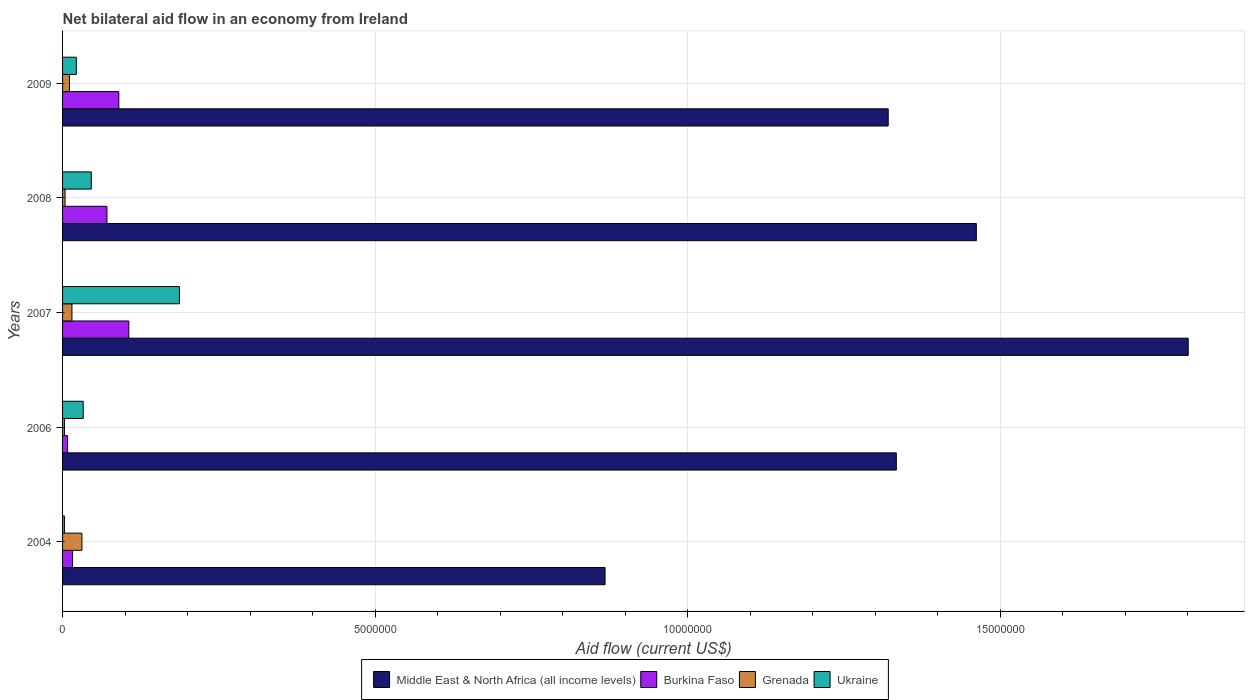How many different coloured bars are there?
Provide a short and direct response. 4. How many groups of bars are there?
Your answer should be very brief. 5. Are the number of bars on each tick of the Y-axis equal?
Your answer should be very brief. Yes. In how many cases, is the number of bars for a given year not equal to the number of legend labels?
Provide a succinct answer. 0. Across all years, what is the maximum net bilateral aid flow in Middle East & North Africa (all income levels)?
Make the answer very short. 1.80e+07. Across all years, what is the minimum net bilateral aid flow in Burkina Faso?
Keep it short and to the point. 8.00e+04. In which year was the net bilateral aid flow in Ukraine maximum?
Provide a succinct answer. 2007. What is the total net bilateral aid flow in Ukraine in the graph?
Ensure brevity in your answer.  2.91e+06. What is the difference between the net bilateral aid flow in Grenada in 2004 and that in 2006?
Keep it short and to the point. 2.80e+05. What is the difference between the net bilateral aid flow in Ukraine in 2004 and the net bilateral aid flow in Burkina Faso in 2007?
Keep it short and to the point. -1.03e+06. What is the average net bilateral aid flow in Ukraine per year?
Make the answer very short. 5.82e+05. In the year 2006, what is the difference between the net bilateral aid flow in Middle East & North Africa (all income levels) and net bilateral aid flow in Burkina Faso?
Your answer should be very brief. 1.33e+07. What is the ratio of the net bilateral aid flow in Burkina Faso in 2004 to that in 2009?
Your answer should be very brief. 0.18. Is the net bilateral aid flow in Middle East & North Africa (all income levels) in 2006 less than that in 2008?
Ensure brevity in your answer.  Yes. What is the difference between the highest and the second highest net bilateral aid flow in Burkina Faso?
Ensure brevity in your answer.  1.60e+05. What is the difference between the highest and the lowest net bilateral aid flow in Middle East & North Africa (all income levels)?
Ensure brevity in your answer.  9.33e+06. What does the 3rd bar from the top in 2006 represents?
Offer a terse response. Burkina Faso. What does the 4th bar from the bottom in 2004 represents?
Your answer should be very brief. Ukraine. Is it the case that in every year, the sum of the net bilateral aid flow in Ukraine and net bilateral aid flow in Middle East & North Africa (all income levels) is greater than the net bilateral aid flow in Grenada?
Ensure brevity in your answer.  Yes. Are all the bars in the graph horizontal?
Give a very brief answer. Yes. How many years are there in the graph?
Provide a succinct answer. 5. What is the difference between two consecutive major ticks on the X-axis?
Offer a very short reply. 5.00e+06. Does the graph contain any zero values?
Provide a short and direct response. No. Does the graph contain grids?
Provide a short and direct response. Yes. How are the legend labels stacked?
Offer a terse response. Horizontal. What is the title of the graph?
Your response must be concise. Net bilateral aid flow in an economy from Ireland. What is the label or title of the X-axis?
Your response must be concise. Aid flow (current US$). What is the Aid flow (current US$) of Middle East & North Africa (all income levels) in 2004?
Provide a short and direct response. 8.68e+06. What is the Aid flow (current US$) of Grenada in 2004?
Your answer should be very brief. 3.10e+05. What is the Aid flow (current US$) in Ukraine in 2004?
Provide a short and direct response. 3.00e+04. What is the Aid flow (current US$) of Middle East & North Africa (all income levels) in 2006?
Your answer should be very brief. 1.33e+07. What is the Aid flow (current US$) of Burkina Faso in 2006?
Make the answer very short. 8.00e+04. What is the Aid flow (current US$) in Grenada in 2006?
Give a very brief answer. 3.00e+04. What is the Aid flow (current US$) in Middle East & North Africa (all income levels) in 2007?
Offer a terse response. 1.80e+07. What is the Aid flow (current US$) in Burkina Faso in 2007?
Your answer should be compact. 1.06e+06. What is the Aid flow (current US$) in Ukraine in 2007?
Give a very brief answer. 1.87e+06. What is the Aid flow (current US$) of Middle East & North Africa (all income levels) in 2008?
Give a very brief answer. 1.46e+07. What is the Aid flow (current US$) of Burkina Faso in 2008?
Ensure brevity in your answer.  7.10e+05. What is the Aid flow (current US$) in Middle East & North Africa (all income levels) in 2009?
Give a very brief answer. 1.32e+07. What is the Aid flow (current US$) in Burkina Faso in 2009?
Keep it short and to the point. 9.00e+05. What is the Aid flow (current US$) of Grenada in 2009?
Keep it short and to the point. 1.10e+05. Across all years, what is the maximum Aid flow (current US$) of Middle East & North Africa (all income levels)?
Provide a short and direct response. 1.80e+07. Across all years, what is the maximum Aid flow (current US$) of Burkina Faso?
Make the answer very short. 1.06e+06. Across all years, what is the maximum Aid flow (current US$) in Grenada?
Offer a terse response. 3.10e+05. Across all years, what is the maximum Aid flow (current US$) of Ukraine?
Provide a succinct answer. 1.87e+06. Across all years, what is the minimum Aid flow (current US$) of Middle East & North Africa (all income levels)?
Offer a terse response. 8.68e+06. Across all years, what is the minimum Aid flow (current US$) of Burkina Faso?
Offer a very short reply. 8.00e+04. Across all years, what is the minimum Aid flow (current US$) in Ukraine?
Make the answer very short. 3.00e+04. What is the total Aid flow (current US$) in Middle East & North Africa (all income levels) in the graph?
Provide a succinct answer. 6.79e+07. What is the total Aid flow (current US$) of Burkina Faso in the graph?
Offer a very short reply. 2.91e+06. What is the total Aid flow (current US$) of Grenada in the graph?
Make the answer very short. 6.40e+05. What is the total Aid flow (current US$) of Ukraine in the graph?
Provide a short and direct response. 2.91e+06. What is the difference between the Aid flow (current US$) of Middle East & North Africa (all income levels) in 2004 and that in 2006?
Provide a short and direct response. -4.66e+06. What is the difference between the Aid flow (current US$) in Burkina Faso in 2004 and that in 2006?
Your answer should be compact. 8.00e+04. What is the difference between the Aid flow (current US$) of Grenada in 2004 and that in 2006?
Keep it short and to the point. 2.80e+05. What is the difference between the Aid flow (current US$) in Ukraine in 2004 and that in 2006?
Your response must be concise. -3.00e+05. What is the difference between the Aid flow (current US$) of Middle East & North Africa (all income levels) in 2004 and that in 2007?
Your response must be concise. -9.33e+06. What is the difference between the Aid flow (current US$) in Burkina Faso in 2004 and that in 2007?
Your response must be concise. -9.00e+05. What is the difference between the Aid flow (current US$) of Ukraine in 2004 and that in 2007?
Your answer should be compact. -1.84e+06. What is the difference between the Aid flow (current US$) in Middle East & North Africa (all income levels) in 2004 and that in 2008?
Keep it short and to the point. -5.94e+06. What is the difference between the Aid flow (current US$) of Burkina Faso in 2004 and that in 2008?
Provide a succinct answer. -5.50e+05. What is the difference between the Aid flow (current US$) of Ukraine in 2004 and that in 2008?
Make the answer very short. -4.30e+05. What is the difference between the Aid flow (current US$) of Middle East & North Africa (all income levels) in 2004 and that in 2009?
Make the answer very short. -4.53e+06. What is the difference between the Aid flow (current US$) in Burkina Faso in 2004 and that in 2009?
Offer a terse response. -7.40e+05. What is the difference between the Aid flow (current US$) in Grenada in 2004 and that in 2009?
Ensure brevity in your answer.  2.00e+05. What is the difference between the Aid flow (current US$) of Ukraine in 2004 and that in 2009?
Your answer should be compact. -1.90e+05. What is the difference between the Aid flow (current US$) of Middle East & North Africa (all income levels) in 2006 and that in 2007?
Your answer should be very brief. -4.67e+06. What is the difference between the Aid flow (current US$) in Burkina Faso in 2006 and that in 2007?
Keep it short and to the point. -9.80e+05. What is the difference between the Aid flow (current US$) in Grenada in 2006 and that in 2007?
Give a very brief answer. -1.20e+05. What is the difference between the Aid flow (current US$) of Ukraine in 2006 and that in 2007?
Make the answer very short. -1.54e+06. What is the difference between the Aid flow (current US$) in Middle East & North Africa (all income levels) in 2006 and that in 2008?
Your answer should be very brief. -1.28e+06. What is the difference between the Aid flow (current US$) in Burkina Faso in 2006 and that in 2008?
Offer a terse response. -6.30e+05. What is the difference between the Aid flow (current US$) of Grenada in 2006 and that in 2008?
Provide a succinct answer. -10000. What is the difference between the Aid flow (current US$) of Burkina Faso in 2006 and that in 2009?
Provide a succinct answer. -8.20e+05. What is the difference between the Aid flow (current US$) of Grenada in 2006 and that in 2009?
Offer a very short reply. -8.00e+04. What is the difference between the Aid flow (current US$) of Ukraine in 2006 and that in 2009?
Your response must be concise. 1.10e+05. What is the difference between the Aid flow (current US$) of Middle East & North Africa (all income levels) in 2007 and that in 2008?
Your answer should be compact. 3.39e+06. What is the difference between the Aid flow (current US$) in Grenada in 2007 and that in 2008?
Provide a short and direct response. 1.10e+05. What is the difference between the Aid flow (current US$) of Ukraine in 2007 and that in 2008?
Provide a succinct answer. 1.41e+06. What is the difference between the Aid flow (current US$) in Middle East & North Africa (all income levels) in 2007 and that in 2009?
Ensure brevity in your answer.  4.80e+06. What is the difference between the Aid flow (current US$) in Burkina Faso in 2007 and that in 2009?
Offer a terse response. 1.60e+05. What is the difference between the Aid flow (current US$) of Ukraine in 2007 and that in 2009?
Make the answer very short. 1.65e+06. What is the difference between the Aid flow (current US$) of Middle East & North Africa (all income levels) in 2008 and that in 2009?
Make the answer very short. 1.41e+06. What is the difference between the Aid flow (current US$) of Burkina Faso in 2008 and that in 2009?
Ensure brevity in your answer.  -1.90e+05. What is the difference between the Aid flow (current US$) in Grenada in 2008 and that in 2009?
Keep it short and to the point. -7.00e+04. What is the difference between the Aid flow (current US$) of Ukraine in 2008 and that in 2009?
Offer a very short reply. 2.40e+05. What is the difference between the Aid flow (current US$) in Middle East & North Africa (all income levels) in 2004 and the Aid flow (current US$) in Burkina Faso in 2006?
Give a very brief answer. 8.60e+06. What is the difference between the Aid flow (current US$) of Middle East & North Africa (all income levels) in 2004 and the Aid flow (current US$) of Grenada in 2006?
Your answer should be compact. 8.65e+06. What is the difference between the Aid flow (current US$) in Middle East & North Africa (all income levels) in 2004 and the Aid flow (current US$) in Ukraine in 2006?
Provide a succinct answer. 8.35e+06. What is the difference between the Aid flow (current US$) of Burkina Faso in 2004 and the Aid flow (current US$) of Grenada in 2006?
Your answer should be very brief. 1.30e+05. What is the difference between the Aid flow (current US$) in Burkina Faso in 2004 and the Aid flow (current US$) in Ukraine in 2006?
Provide a succinct answer. -1.70e+05. What is the difference between the Aid flow (current US$) in Grenada in 2004 and the Aid flow (current US$) in Ukraine in 2006?
Your response must be concise. -2.00e+04. What is the difference between the Aid flow (current US$) in Middle East & North Africa (all income levels) in 2004 and the Aid flow (current US$) in Burkina Faso in 2007?
Provide a succinct answer. 7.62e+06. What is the difference between the Aid flow (current US$) of Middle East & North Africa (all income levels) in 2004 and the Aid flow (current US$) of Grenada in 2007?
Your answer should be compact. 8.53e+06. What is the difference between the Aid flow (current US$) of Middle East & North Africa (all income levels) in 2004 and the Aid flow (current US$) of Ukraine in 2007?
Your response must be concise. 6.81e+06. What is the difference between the Aid flow (current US$) in Burkina Faso in 2004 and the Aid flow (current US$) in Ukraine in 2007?
Provide a succinct answer. -1.71e+06. What is the difference between the Aid flow (current US$) of Grenada in 2004 and the Aid flow (current US$) of Ukraine in 2007?
Your answer should be compact. -1.56e+06. What is the difference between the Aid flow (current US$) of Middle East & North Africa (all income levels) in 2004 and the Aid flow (current US$) of Burkina Faso in 2008?
Make the answer very short. 7.97e+06. What is the difference between the Aid flow (current US$) of Middle East & North Africa (all income levels) in 2004 and the Aid flow (current US$) of Grenada in 2008?
Provide a succinct answer. 8.64e+06. What is the difference between the Aid flow (current US$) in Middle East & North Africa (all income levels) in 2004 and the Aid flow (current US$) in Ukraine in 2008?
Ensure brevity in your answer.  8.22e+06. What is the difference between the Aid flow (current US$) in Burkina Faso in 2004 and the Aid flow (current US$) in Grenada in 2008?
Make the answer very short. 1.20e+05. What is the difference between the Aid flow (current US$) of Middle East & North Africa (all income levels) in 2004 and the Aid flow (current US$) of Burkina Faso in 2009?
Your answer should be very brief. 7.78e+06. What is the difference between the Aid flow (current US$) in Middle East & North Africa (all income levels) in 2004 and the Aid flow (current US$) in Grenada in 2009?
Give a very brief answer. 8.57e+06. What is the difference between the Aid flow (current US$) in Middle East & North Africa (all income levels) in 2004 and the Aid flow (current US$) in Ukraine in 2009?
Provide a short and direct response. 8.46e+06. What is the difference between the Aid flow (current US$) in Burkina Faso in 2004 and the Aid flow (current US$) in Grenada in 2009?
Your response must be concise. 5.00e+04. What is the difference between the Aid flow (current US$) of Burkina Faso in 2004 and the Aid flow (current US$) of Ukraine in 2009?
Your response must be concise. -6.00e+04. What is the difference between the Aid flow (current US$) in Grenada in 2004 and the Aid flow (current US$) in Ukraine in 2009?
Offer a terse response. 9.00e+04. What is the difference between the Aid flow (current US$) in Middle East & North Africa (all income levels) in 2006 and the Aid flow (current US$) in Burkina Faso in 2007?
Provide a short and direct response. 1.23e+07. What is the difference between the Aid flow (current US$) of Middle East & North Africa (all income levels) in 2006 and the Aid flow (current US$) of Grenada in 2007?
Ensure brevity in your answer.  1.32e+07. What is the difference between the Aid flow (current US$) of Middle East & North Africa (all income levels) in 2006 and the Aid flow (current US$) of Ukraine in 2007?
Your answer should be compact. 1.15e+07. What is the difference between the Aid flow (current US$) in Burkina Faso in 2006 and the Aid flow (current US$) in Ukraine in 2007?
Ensure brevity in your answer.  -1.79e+06. What is the difference between the Aid flow (current US$) in Grenada in 2006 and the Aid flow (current US$) in Ukraine in 2007?
Offer a terse response. -1.84e+06. What is the difference between the Aid flow (current US$) in Middle East & North Africa (all income levels) in 2006 and the Aid flow (current US$) in Burkina Faso in 2008?
Your answer should be compact. 1.26e+07. What is the difference between the Aid flow (current US$) in Middle East & North Africa (all income levels) in 2006 and the Aid flow (current US$) in Grenada in 2008?
Give a very brief answer. 1.33e+07. What is the difference between the Aid flow (current US$) in Middle East & North Africa (all income levels) in 2006 and the Aid flow (current US$) in Ukraine in 2008?
Ensure brevity in your answer.  1.29e+07. What is the difference between the Aid flow (current US$) of Burkina Faso in 2006 and the Aid flow (current US$) of Ukraine in 2008?
Make the answer very short. -3.80e+05. What is the difference between the Aid flow (current US$) of Grenada in 2006 and the Aid flow (current US$) of Ukraine in 2008?
Offer a terse response. -4.30e+05. What is the difference between the Aid flow (current US$) of Middle East & North Africa (all income levels) in 2006 and the Aid flow (current US$) of Burkina Faso in 2009?
Offer a very short reply. 1.24e+07. What is the difference between the Aid flow (current US$) in Middle East & North Africa (all income levels) in 2006 and the Aid flow (current US$) in Grenada in 2009?
Give a very brief answer. 1.32e+07. What is the difference between the Aid flow (current US$) of Middle East & North Africa (all income levels) in 2006 and the Aid flow (current US$) of Ukraine in 2009?
Your response must be concise. 1.31e+07. What is the difference between the Aid flow (current US$) in Burkina Faso in 2006 and the Aid flow (current US$) in Grenada in 2009?
Your answer should be compact. -3.00e+04. What is the difference between the Aid flow (current US$) of Burkina Faso in 2006 and the Aid flow (current US$) of Ukraine in 2009?
Provide a short and direct response. -1.40e+05. What is the difference between the Aid flow (current US$) of Middle East & North Africa (all income levels) in 2007 and the Aid flow (current US$) of Burkina Faso in 2008?
Offer a terse response. 1.73e+07. What is the difference between the Aid flow (current US$) of Middle East & North Africa (all income levels) in 2007 and the Aid flow (current US$) of Grenada in 2008?
Provide a short and direct response. 1.80e+07. What is the difference between the Aid flow (current US$) of Middle East & North Africa (all income levels) in 2007 and the Aid flow (current US$) of Ukraine in 2008?
Ensure brevity in your answer.  1.76e+07. What is the difference between the Aid flow (current US$) of Burkina Faso in 2007 and the Aid flow (current US$) of Grenada in 2008?
Offer a very short reply. 1.02e+06. What is the difference between the Aid flow (current US$) of Grenada in 2007 and the Aid flow (current US$) of Ukraine in 2008?
Your response must be concise. -3.10e+05. What is the difference between the Aid flow (current US$) in Middle East & North Africa (all income levels) in 2007 and the Aid flow (current US$) in Burkina Faso in 2009?
Your response must be concise. 1.71e+07. What is the difference between the Aid flow (current US$) of Middle East & North Africa (all income levels) in 2007 and the Aid flow (current US$) of Grenada in 2009?
Provide a short and direct response. 1.79e+07. What is the difference between the Aid flow (current US$) in Middle East & North Africa (all income levels) in 2007 and the Aid flow (current US$) in Ukraine in 2009?
Your answer should be very brief. 1.78e+07. What is the difference between the Aid flow (current US$) in Burkina Faso in 2007 and the Aid flow (current US$) in Grenada in 2009?
Make the answer very short. 9.50e+05. What is the difference between the Aid flow (current US$) of Burkina Faso in 2007 and the Aid flow (current US$) of Ukraine in 2009?
Provide a short and direct response. 8.40e+05. What is the difference between the Aid flow (current US$) in Grenada in 2007 and the Aid flow (current US$) in Ukraine in 2009?
Your answer should be very brief. -7.00e+04. What is the difference between the Aid flow (current US$) in Middle East & North Africa (all income levels) in 2008 and the Aid flow (current US$) in Burkina Faso in 2009?
Give a very brief answer. 1.37e+07. What is the difference between the Aid flow (current US$) of Middle East & North Africa (all income levels) in 2008 and the Aid flow (current US$) of Grenada in 2009?
Ensure brevity in your answer.  1.45e+07. What is the difference between the Aid flow (current US$) of Middle East & North Africa (all income levels) in 2008 and the Aid flow (current US$) of Ukraine in 2009?
Provide a succinct answer. 1.44e+07. What is the difference between the Aid flow (current US$) of Burkina Faso in 2008 and the Aid flow (current US$) of Grenada in 2009?
Your response must be concise. 6.00e+05. What is the difference between the Aid flow (current US$) in Grenada in 2008 and the Aid flow (current US$) in Ukraine in 2009?
Offer a very short reply. -1.80e+05. What is the average Aid flow (current US$) in Middle East & North Africa (all income levels) per year?
Provide a short and direct response. 1.36e+07. What is the average Aid flow (current US$) in Burkina Faso per year?
Offer a terse response. 5.82e+05. What is the average Aid flow (current US$) in Grenada per year?
Your response must be concise. 1.28e+05. What is the average Aid flow (current US$) of Ukraine per year?
Provide a short and direct response. 5.82e+05. In the year 2004, what is the difference between the Aid flow (current US$) in Middle East & North Africa (all income levels) and Aid flow (current US$) in Burkina Faso?
Make the answer very short. 8.52e+06. In the year 2004, what is the difference between the Aid flow (current US$) of Middle East & North Africa (all income levels) and Aid flow (current US$) of Grenada?
Provide a succinct answer. 8.37e+06. In the year 2004, what is the difference between the Aid flow (current US$) in Middle East & North Africa (all income levels) and Aid flow (current US$) in Ukraine?
Your answer should be very brief. 8.65e+06. In the year 2004, what is the difference between the Aid flow (current US$) of Burkina Faso and Aid flow (current US$) of Grenada?
Provide a short and direct response. -1.50e+05. In the year 2006, what is the difference between the Aid flow (current US$) of Middle East & North Africa (all income levels) and Aid flow (current US$) of Burkina Faso?
Your answer should be very brief. 1.33e+07. In the year 2006, what is the difference between the Aid flow (current US$) in Middle East & North Africa (all income levels) and Aid flow (current US$) in Grenada?
Your answer should be compact. 1.33e+07. In the year 2006, what is the difference between the Aid flow (current US$) in Middle East & North Africa (all income levels) and Aid flow (current US$) in Ukraine?
Your response must be concise. 1.30e+07. In the year 2007, what is the difference between the Aid flow (current US$) of Middle East & North Africa (all income levels) and Aid flow (current US$) of Burkina Faso?
Provide a succinct answer. 1.70e+07. In the year 2007, what is the difference between the Aid flow (current US$) of Middle East & North Africa (all income levels) and Aid flow (current US$) of Grenada?
Provide a succinct answer. 1.79e+07. In the year 2007, what is the difference between the Aid flow (current US$) in Middle East & North Africa (all income levels) and Aid flow (current US$) in Ukraine?
Offer a terse response. 1.61e+07. In the year 2007, what is the difference between the Aid flow (current US$) in Burkina Faso and Aid flow (current US$) in Grenada?
Your answer should be very brief. 9.10e+05. In the year 2007, what is the difference between the Aid flow (current US$) in Burkina Faso and Aid flow (current US$) in Ukraine?
Offer a terse response. -8.10e+05. In the year 2007, what is the difference between the Aid flow (current US$) in Grenada and Aid flow (current US$) in Ukraine?
Your response must be concise. -1.72e+06. In the year 2008, what is the difference between the Aid flow (current US$) in Middle East & North Africa (all income levels) and Aid flow (current US$) in Burkina Faso?
Ensure brevity in your answer.  1.39e+07. In the year 2008, what is the difference between the Aid flow (current US$) of Middle East & North Africa (all income levels) and Aid flow (current US$) of Grenada?
Your answer should be compact. 1.46e+07. In the year 2008, what is the difference between the Aid flow (current US$) in Middle East & North Africa (all income levels) and Aid flow (current US$) in Ukraine?
Provide a succinct answer. 1.42e+07. In the year 2008, what is the difference between the Aid flow (current US$) of Burkina Faso and Aid flow (current US$) of Grenada?
Offer a very short reply. 6.70e+05. In the year 2008, what is the difference between the Aid flow (current US$) in Grenada and Aid flow (current US$) in Ukraine?
Ensure brevity in your answer.  -4.20e+05. In the year 2009, what is the difference between the Aid flow (current US$) in Middle East & North Africa (all income levels) and Aid flow (current US$) in Burkina Faso?
Give a very brief answer. 1.23e+07. In the year 2009, what is the difference between the Aid flow (current US$) in Middle East & North Africa (all income levels) and Aid flow (current US$) in Grenada?
Provide a succinct answer. 1.31e+07. In the year 2009, what is the difference between the Aid flow (current US$) in Middle East & North Africa (all income levels) and Aid flow (current US$) in Ukraine?
Your answer should be very brief. 1.30e+07. In the year 2009, what is the difference between the Aid flow (current US$) in Burkina Faso and Aid flow (current US$) in Grenada?
Provide a short and direct response. 7.90e+05. In the year 2009, what is the difference between the Aid flow (current US$) in Burkina Faso and Aid flow (current US$) in Ukraine?
Offer a very short reply. 6.80e+05. In the year 2009, what is the difference between the Aid flow (current US$) of Grenada and Aid flow (current US$) of Ukraine?
Your answer should be very brief. -1.10e+05. What is the ratio of the Aid flow (current US$) in Middle East & North Africa (all income levels) in 2004 to that in 2006?
Offer a very short reply. 0.65. What is the ratio of the Aid flow (current US$) in Burkina Faso in 2004 to that in 2006?
Your response must be concise. 2. What is the ratio of the Aid flow (current US$) of Grenada in 2004 to that in 2006?
Offer a very short reply. 10.33. What is the ratio of the Aid flow (current US$) in Ukraine in 2004 to that in 2006?
Your answer should be very brief. 0.09. What is the ratio of the Aid flow (current US$) in Middle East & North Africa (all income levels) in 2004 to that in 2007?
Your answer should be very brief. 0.48. What is the ratio of the Aid flow (current US$) in Burkina Faso in 2004 to that in 2007?
Your response must be concise. 0.15. What is the ratio of the Aid flow (current US$) in Grenada in 2004 to that in 2007?
Give a very brief answer. 2.07. What is the ratio of the Aid flow (current US$) in Ukraine in 2004 to that in 2007?
Offer a terse response. 0.02. What is the ratio of the Aid flow (current US$) in Middle East & North Africa (all income levels) in 2004 to that in 2008?
Provide a succinct answer. 0.59. What is the ratio of the Aid flow (current US$) in Burkina Faso in 2004 to that in 2008?
Make the answer very short. 0.23. What is the ratio of the Aid flow (current US$) in Grenada in 2004 to that in 2008?
Provide a succinct answer. 7.75. What is the ratio of the Aid flow (current US$) of Ukraine in 2004 to that in 2008?
Offer a very short reply. 0.07. What is the ratio of the Aid flow (current US$) of Middle East & North Africa (all income levels) in 2004 to that in 2009?
Your answer should be very brief. 0.66. What is the ratio of the Aid flow (current US$) of Burkina Faso in 2004 to that in 2009?
Provide a short and direct response. 0.18. What is the ratio of the Aid flow (current US$) of Grenada in 2004 to that in 2009?
Offer a terse response. 2.82. What is the ratio of the Aid flow (current US$) of Ukraine in 2004 to that in 2009?
Offer a very short reply. 0.14. What is the ratio of the Aid flow (current US$) in Middle East & North Africa (all income levels) in 2006 to that in 2007?
Provide a succinct answer. 0.74. What is the ratio of the Aid flow (current US$) of Burkina Faso in 2006 to that in 2007?
Offer a very short reply. 0.08. What is the ratio of the Aid flow (current US$) in Ukraine in 2006 to that in 2007?
Provide a succinct answer. 0.18. What is the ratio of the Aid flow (current US$) of Middle East & North Africa (all income levels) in 2006 to that in 2008?
Offer a terse response. 0.91. What is the ratio of the Aid flow (current US$) of Burkina Faso in 2006 to that in 2008?
Your answer should be compact. 0.11. What is the ratio of the Aid flow (current US$) of Grenada in 2006 to that in 2008?
Provide a succinct answer. 0.75. What is the ratio of the Aid flow (current US$) in Ukraine in 2006 to that in 2008?
Your response must be concise. 0.72. What is the ratio of the Aid flow (current US$) in Middle East & North Africa (all income levels) in 2006 to that in 2009?
Provide a succinct answer. 1.01. What is the ratio of the Aid flow (current US$) of Burkina Faso in 2006 to that in 2009?
Offer a very short reply. 0.09. What is the ratio of the Aid flow (current US$) in Grenada in 2006 to that in 2009?
Offer a very short reply. 0.27. What is the ratio of the Aid flow (current US$) in Middle East & North Africa (all income levels) in 2007 to that in 2008?
Give a very brief answer. 1.23. What is the ratio of the Aid flow (current US$) of Burkina Faso in 2007 to that in 2008?
Ensure brevity in your answer.  1.49. What is the ratio of the Aid flow (current US$) of Grenada in 2007 to that in 2008?
Keep it short and to the point. 3.75. What is the ratio of the Aid flow (current US$) in Ukraine in 2007 to that in 2008?
Give a very brief answer. 4.07. What is the ratio of the Aid flow (current US$) in Middle East & North Africa (all income levels) in 2007 to that in 2009?
Give a very brief answer. 1.36. What is the ratio of the Aid flow (current US$) in Burkina Faso in 2007 to that in 2009?
Provide a succinct answer. 1.18. What is the ratio of the Aid flow (current US$) in Grenada in 2007 to that in 2009?
Your answer should be compact. 1.36. What is the ratio of the Aid flow (current US$) in Ukraine in 2007 to that in 2009?
Make the answer very short. 8.5. What is the ratio of the Aid flow (current US$) in Middle East & North Africa (all income levels) in 2008 to that in 2009?
Your response must be concise. 1.11. What is the ratio of the Aid flow (current US$) of Burkina Faso in 2008 to that in 2009?
Your answer should be compact. 0.79. What is the ratio of the Aid flow (current US$) of Grenada in 2008 to that in 2009?
Offer a terse response. 0.36. What is the ratio of the Aid flow (current US$) of Ukraine in 2008 to that in 2009?
Your response must be concise. 2.09. What is the difference between the highest and the second highest Aid flow (current US$) in Middle East & North Africa (all income levels)?
Provide a succinct answer. 3.39e+06. What is the difference between the highest and the second highest Aid flow (current US$) of Grenada?
Offer a very short reply. 1.60e+05. What is the difference between the highest and the second highest Aid flow (current US$) of Ukraine?
Ensure brevity in your answer.  1.41e+06. What is the difference between the highest and the lowest Aid flow (current US$) of Middle East & North Africa (all income levels)?
Ensure brevity in your answer.  9.33e+06. What is the difference between the highest and the lowest Aid flow (current US$) in Burkina Faso?
Provide a succinct answer. 9.80e+05. What is the difference between the highest and the lowest Aid flow (current US$) in Grenada?
Keep it short and to the point. 2.80e+05. What is the difference between the highest and the lowest Aid flow (current US$) of Ukraine?
Keep it short and to the point. 1.84e+06. 